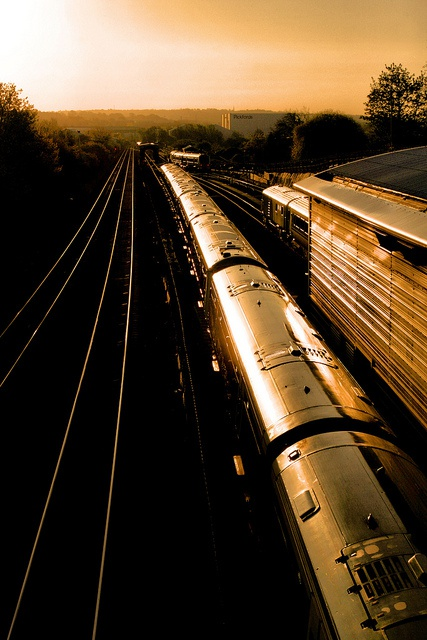Describe the objects in this image and their specific colors. I can see train in white, black, and olive tones and train in white, brown, black, orange, and maroon tones in this image. 